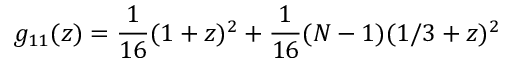Convert formula to latex. <formula><loc_0><loc_0><loc_500><loc_500>g _ { 1 1 } ( z ) = \frac { 1 } { 1 6 } ( 1 + z ) ^ { 2 } + \frac { 1 } { 1 6 } ( N - 1 ) ( 1 / 3 + z ) ^ { 2 }</formula> 